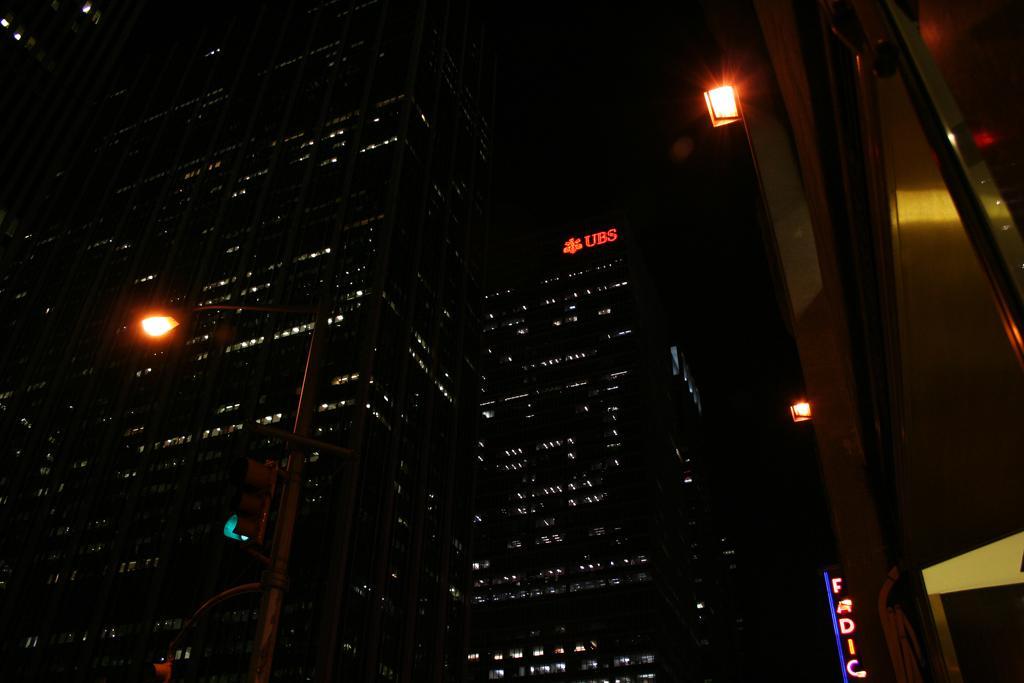Please provide a concise description of this image. The image is captured in the night, there are two tall buildings and some portions of the building are lightened up and in front of the buildings there is a street light and the traffic lights were attached to that. On the right side there is another building. 